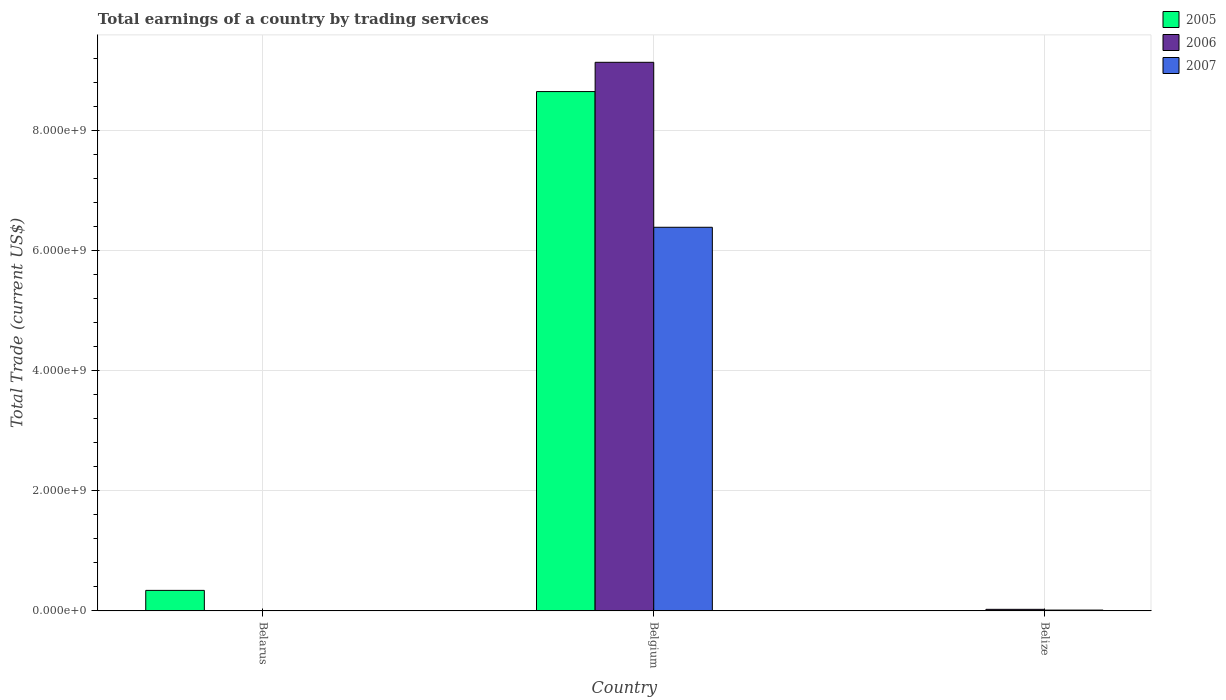How many bars are there on the 3rd tick from the right?
Provide a short and direct response. 1. What is the label of the 3rd group of bars from the left?
Offer a terse response. Belize. What is the total earnings in 2007 in Belgium?
Offer a terse response. 6.39e+09. Across all countries, what is the maximum total earnings in 2005?
Provide a succinct answer. 8.65e+09. Across all countries, what is the minimum total earnings in 2006?
Provide a short and direct response. 0. What is the total total earnings in 2006 in the graph?
Your response must be concise. 9.16e+09. What is the difference between the total earnings in 2006 in Belgium and that in Belize?
Your answer should be compact. 9.11e+09. What is the difference between the total earnings in 2005 in Belarus and the total earnings in 2006 in Belgium?
Your answer should be very brief. -8.79e+09. What is the average total earnings in 2006 per country?
Your response must be concise. 3.05e+09. What is the difference between the total earnings of/in 2007 and total earnings of/in 2006 in Belize?
Provide a short and direct response. -1.25e+07. In how many countries, is the total earnings in 2005 greater than 5600000000 US$?
Offer a terse response. 1. What is the ratio of the total earnings in 2007 in Belgium to that in Belize?
Your answer should be very brief. 474.01. Is the difference between the total earnings in 2007 in Belgium and Belize greater than the difference between the total earnings in 2006 in Belgium and Belize?
Provide a succinct answer. No. What is the difference between the highest and the lowest total earnings in 2006?
Your answer should be compact. 9.14e+09. Is the sum of the total earnings in 2007 in Belgium and Belize greater than the maximum total earnings in 2005 across all countries?
Provide a succinct answer. No. How many bars are there?
Your answer should be compact. 6. How many countries are there in the graph?
Provide a short and direct response. 3. Does the graph contain any zero values?
Your response must be concise. Yes. Where does the legend appear in the graph?
Your answer should be compact. Top right. How are the legend labels stacked?
Offer a terse response. Vertical. What is the title of the graph?
Your answer should be very brief. Total earnings of a country by trading services. Does "1976" appear as one of the legend labels in the graph?
Offer a very short reply. No. What is the label or title of the Y-axis?
Your answer should be compact. Total Trade (current US$). What is the Total Trade (current US$) of 2005 in Belarus?
Provide a succinct answer. 3.42e+08. What is the Total Trade (current US$) of 2006 in Belarus?
Your response must be concise. 0. What is the Total Trade (current US$) of 2007 in Belarus?
Give a very brief answer. 0. What is the Total Trade (current US$) in 2005 in Belgium?
Provide a succinct answer. 8.65e+09. What is the Total Trade (current US$) in 2006 in Belgium?
Offer a terse response. 9.14e+09. What is the Total Trade (current US$) in 2007 in Belgium?
Provide a short and direct response. 6.39e+09. What is the Total Trade (current US$) in 2005 in Belize?
Provide a short and direct response. 0. What is the Total Trade (current US$) in 2006 in Belize?
Provide a succinct answer. 2.59e+07. What is the Total Trade (current US$) of 2007 in Belize?
Provide a succinct answer. 1.35e+07. Across all countries, what is the maximum Total Trade (current US$) of 2005?
Provide a short and direct response. 8.65e+09. Across all countries, what is the maximum Total Trade (current US$) in 2006?
Your answer should be compact. 9.14e+09. Across all countries, what is the maximum Total Trade (current US$) in 2007?
Provide a short and direct response. 6.39e+09. Across all countries, what is the minimum Total Trade (current US$) of 2005?
Provide a short and direct response. 0. Across all countries, what is the minimum Total Trade (current US$) of 2006?
Your answer should be compact. 0. What is the total Total Trade (current US$) in 2005 in the graph?
Keep it short and to the point. 8.99e+09. What is the total Total Trade (current US$) in 2006 in the graph?
Give a very brief answer. 9.16e+09. What is the total Total Trade (current US$) of 2007 in the graph?
Make the answer very short. 6.40e+09. What is the difference between the Total Trade (current US$) in 2005 in Belarus and that in Belgium?
Give a very brief answer. -8.31e+09. What is the difference between the Total Trade (current US$) of 2006 in Belgium and that in Belize?
Offer a terse response. 9.11e+09. What is the difference between the Total Trade (current US$) in 2007 in Belgium and that in Belize?
Offer a very short reply. 6.37e+09. What is the difference between the Total Trade (current US$) in 2005 in Belarus and the Total Trade (current US$) in 2006 in Belgium?
Offer a terse response. -8.79e+09. What is the difference between the Total Trade (current US$) of 2005 in Belarus and the Total Trade (current US$) of 2007 in Belgium?
Ensure brevity in your answer.  -6.05e+09. What is the difference between the Total Trade (current US$) of 2005 in Belarus and the Total Trade (current US$) of 2006 in Belize?
Give a very brief answer. 3.16e+08. What is the difference between the Total Trade (current US$) of 2005 in Belarus and the Total Trade (current US$) of 2007 in Belize?
Give a very brief answer. 3.28e+08. What is the difference between the Total Trade (current US$) in 2005 in Belgium and the Total Trade (current US$) in 2006 in Belize?
Your answer should be compact. 8.62e+09. What is the difference between the Total Trade (current US$) in 2005 in Belgium and the Total Trade (current US$) in 2007 in Belize?
Keep it short and to the point. 8.63e+09. What is the difference between the Total Trade (current US$) of 2006 in Belgium and the Total Trade (current US$) of 2007 in Belize?
Provide a short and direct response. 9.12e+09. What is the average Total Trade (current US$) in 2005 per country?
Keep it short and to the point. 3.00e+09. What is the average Total Trade (current US$) in 2006 per country?
Provide a succinct answer. 3.05e+09. What is the average Total Trade (current US$) of 2007 per country?
Offer a terse response. 2.13e+09. What is the difference between the Total Trade (current US$) in 2005 and Total Trade (current US$) in 2006 in Belgium?
Your response must be concise. -4.87e+08. What is the difference between the Total Trade (current US$) in 2005 and Total Trade (current US$) in 2007 in Belgium?
Your answer should be compact. 2.26e+09. What is the difference between the Total Trade (current US$) of 2006 and Total Trade (current US$) of 2007 in Belgium?
Ensure brevity in your answer.  2.75e+09. What is the difference between the Total Trade (current US$) of 2006 and Total Trade (current US$) of 2007 in Belize?
Keep it short and to the point. 1.25e+07. What is the ratio of the Total Trade (current US$) in 2005 in Belarus to that in Belgium?
Offer a terse response. 0.04. What is the ratio of the Total Trade (current US$) in 2006 in Belgium to that in Belize?
Offer a terse response. 352.29. What is the ratio of the Total Trade (current US$) in 2007 in Belgium to that in Belize?
Your answer should be very brief. 474.01. What is the difference between the highest and the lowest Total Trade (current US$) in 2005?
Your answer should be compact. 8.65e+09. What is the difference between the highest and the lowest Total Trade (current US$) of 2006?
Provide a short and direct response. 9.14e+09. What is the difference between the highest and the lowest Total Trade (current US$) in 2007?
Keep it short and to the point. 6.39e+09. 